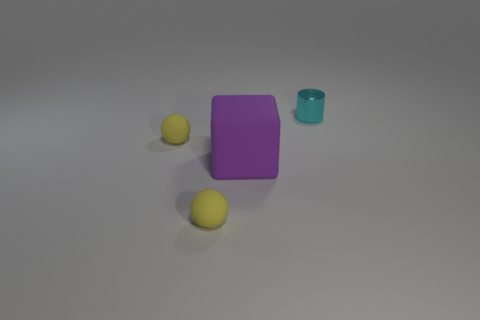What is the size of the yellow sphere in front of the small yellow thing that is behind the purple block?
Offer a very short reply. Small. Are there any tiny yellow things made of the same material as the purple object?
Your response must be concise. Yes. There is a rubber object behind the rubber cube; does it have the same color as the small thing in front of the big matte cube?
Provide a short and direct response. Yes. Is there a yellow rubber sphere in front of the small thing that is right of the large object?
Offer a terse response. Yes. Does the tiny yellow thing behind the big block have the same shape as the tiny cyan shiny thing that is behind the purple object?
Give a very brief answer. No. Does the thing in front of the purple object have the same material as the cyan cylinder behind the purple thing?
Your answer should be very brief. No. What material is the tiny object that is to the right of the rubber object in front of the big purple rubber object made of?
Offer a very short reply. Metal. There is a small object that is right of the tiny ball in front of the rubber thing behind the large rubber cube; what shape is it?
Provide a short and direct response. Cylinder. How many large cubes are there?
Your answer should be compact. 1. The small yellow object behind the large purple rubber block has what shape?
Give a very brief answer. Sphere. 